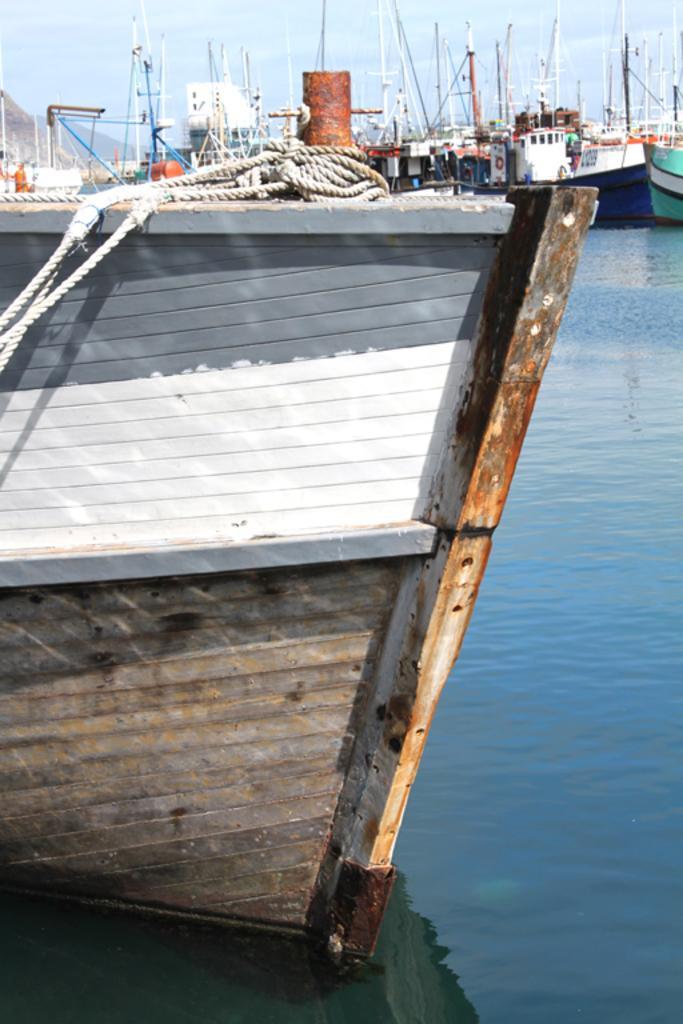Can you describe this image briefly? In this picture i can see ships on the water. In the front of the image we have a ship on which i can see ropes. In the background i can see sky. 